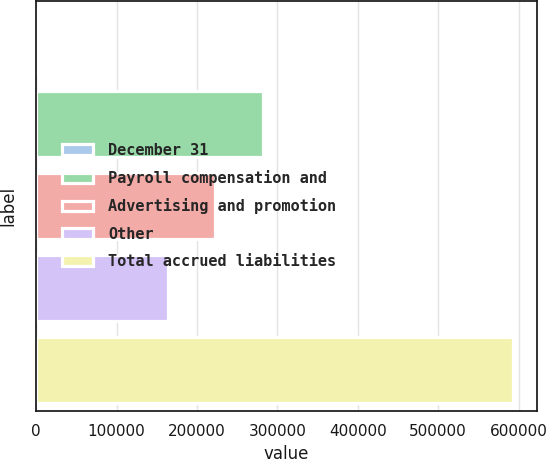Convert chart to OTSL. <chart><loc_0><loc_0><loc_500><loc_500><bar_chart><fcel>December 31<fcel>Payroll compensation and<fcel>Advertising and promotion<fcel>Other<fcel>Total accrued liabilities<nl><fcel>2010<fcel>281672<fcel>222542<fcel>163412<fcel>593308<nl></chart> 